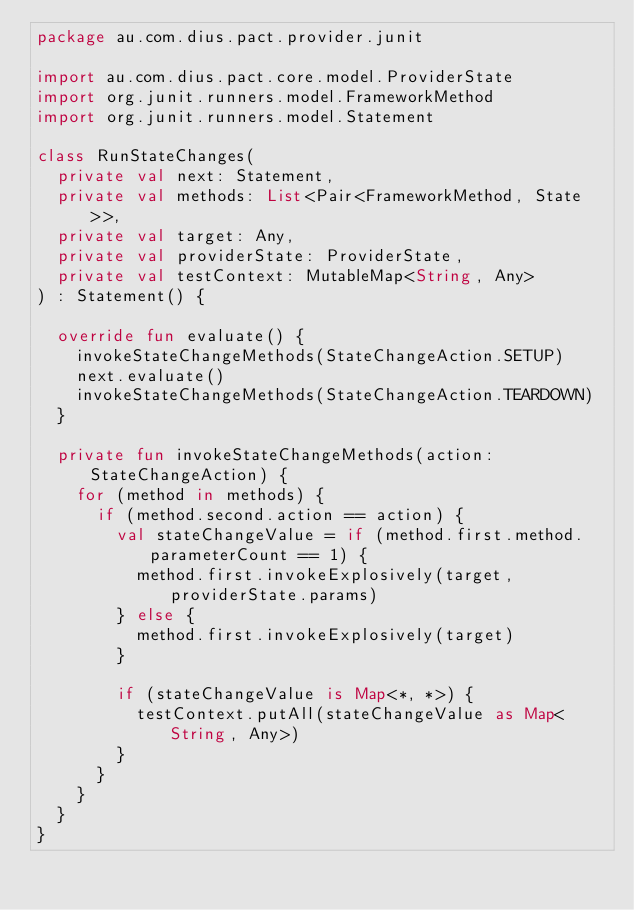Convert code to text. <code><loc_0><loc_0><loc_500><loc_500><_Kotlin_>package au.com.dius.pact.provider.junit

import au.com.dius.pact.core.model.ProviderState
import org.junit.runners.model.FrameworkMethod
import org.junit.runners.model.Statement

class RunStateChanges(
  private val next: Statement,
  private val methods: List<Pair<FrameworkMethod, State>>,
  private val target: Any,
  private val providerState: ProviderState,
  private val testContext: MutableMap<String, Any>
) : Statement() {

  override fun evaluate() {
    invokeStateChangeMethods(StateChangeAction.SETUP)
    next.evaluate()
    invokeStateChangeMethods(StateChangeAction.TEARDOWN)
  }

  private fun invokeStateChangeMethods(action: StateChangeAction) {
    for (method in methods) {
      if (method.second.action == action) {
        val stateChangeValue = if (method.first.method.parameterCount == 1) {
          method.first.invokeExplosively(target, providerState.params)
        } else {
          method.first.invokeExplosively(target)
        }

        if (stateChangeValue is Map<*, *>) {
          testContext.putAll(stateChangeValue as Map<String, Any>)
        }
      }
    }
  }
}
</code> 